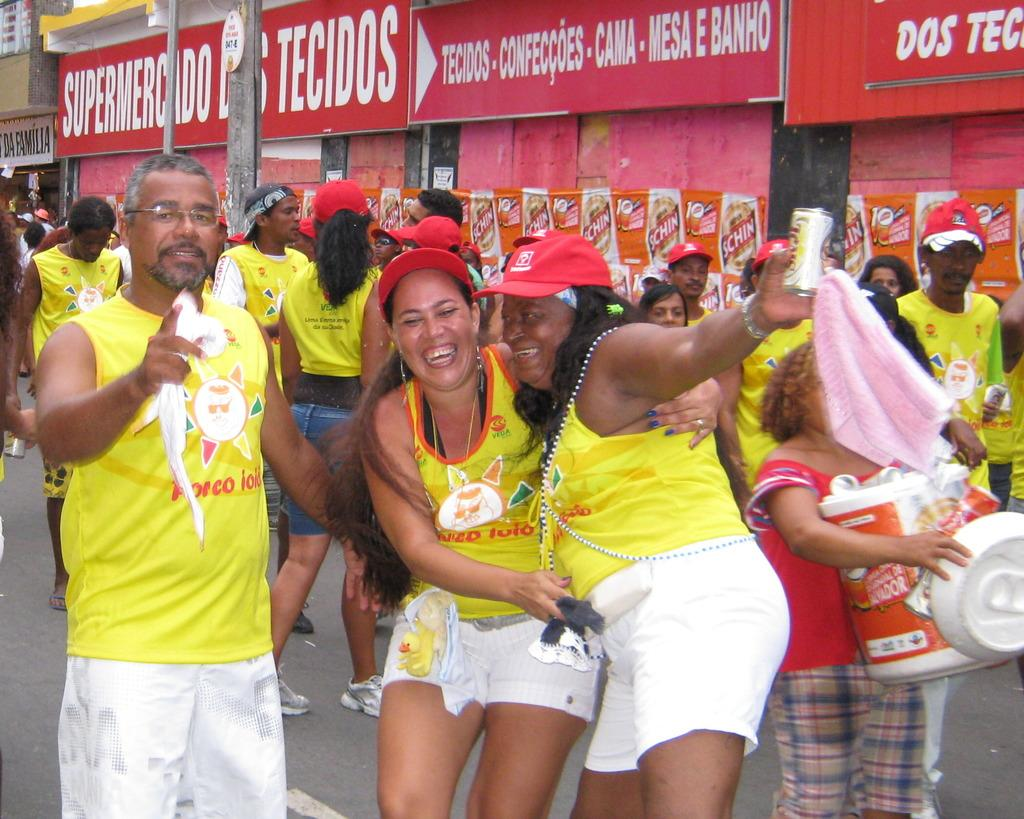How many people are in the foreground of the picture? There are many people in the foreground of the picture. What color are the dresses worn by the people in the image? The people are wearing yellow color dresses. What can be seen in the background of the image? There are boards, banners, poles, and buildings in the background of the image. What type of kettle is being used to draw the banners in the image? There is no kettle present in the image, and banners are not being drawn. Can you tell me how many crayons are used to color the boards in the image? There are no crayons visible in the image, and the boards do not appear to be colored. 